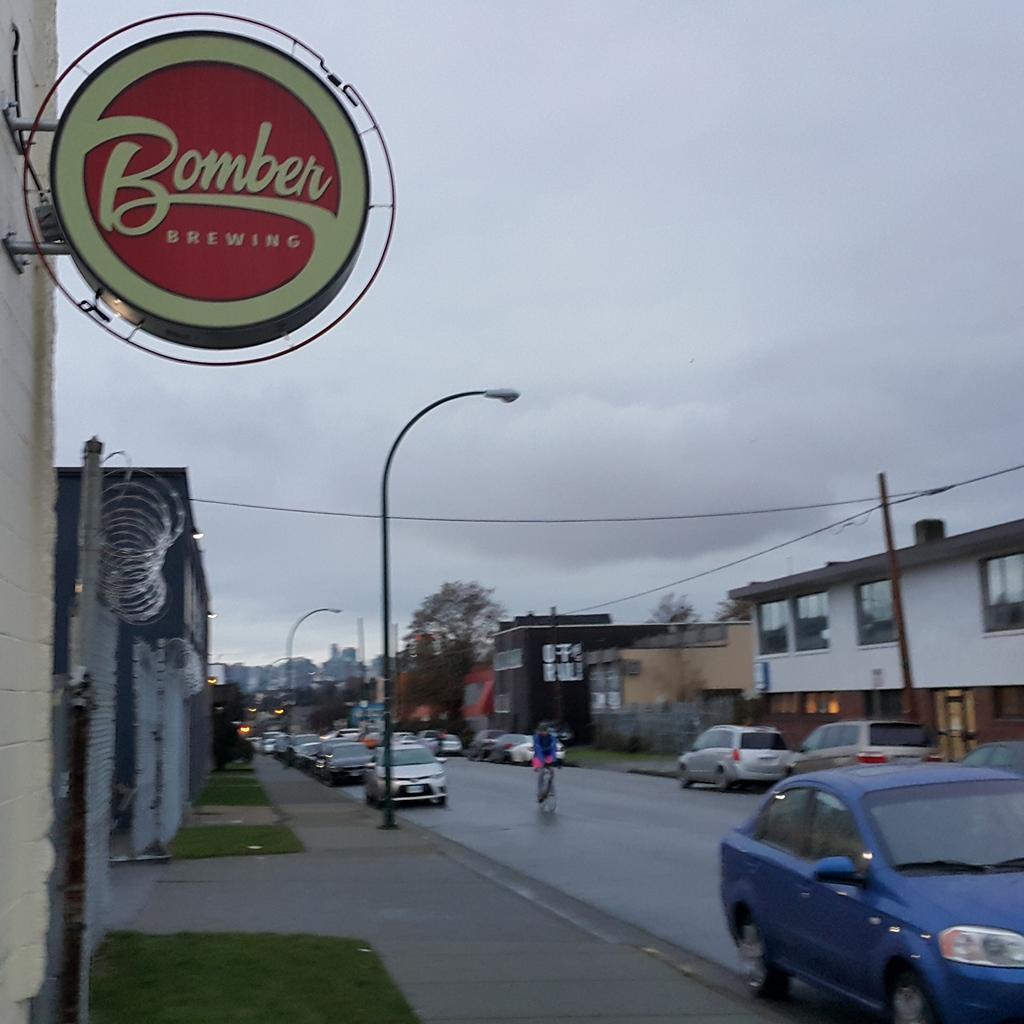In one or two sentences, can you explain what this image depicts? This image consists of many cars parked on the road. At the bottom, there is a road. On the left and right, there are buildings. In the front, we can see a board. At the top, there are clouds in the sky. 